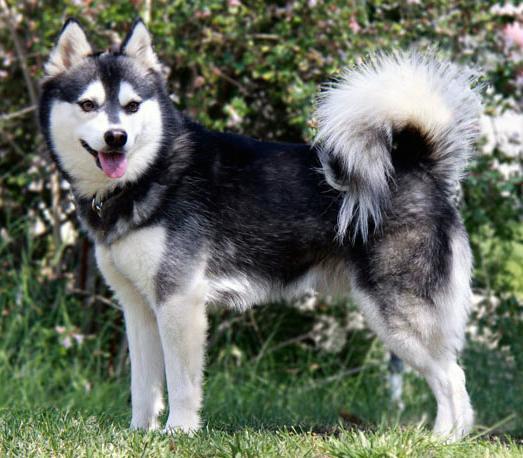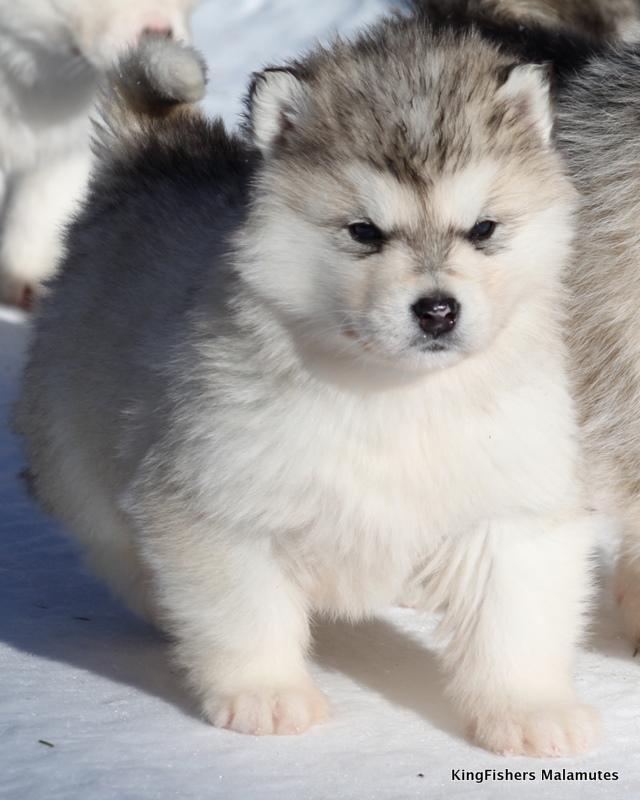The first image is the image on the left, the second image is the image on the right. Given the left and right images, does the statement "One dog is laying down." hold true? Answer yes or no. No. The first image is the image on the left, the second image is the image on the right. Analyze the images presented: Is the assertion "The left image contains a puppy with forward-flopped ears, and the right image contains an adult dog with a closed mouth and non-blue eyes." valid? Answer yes or no. No. 